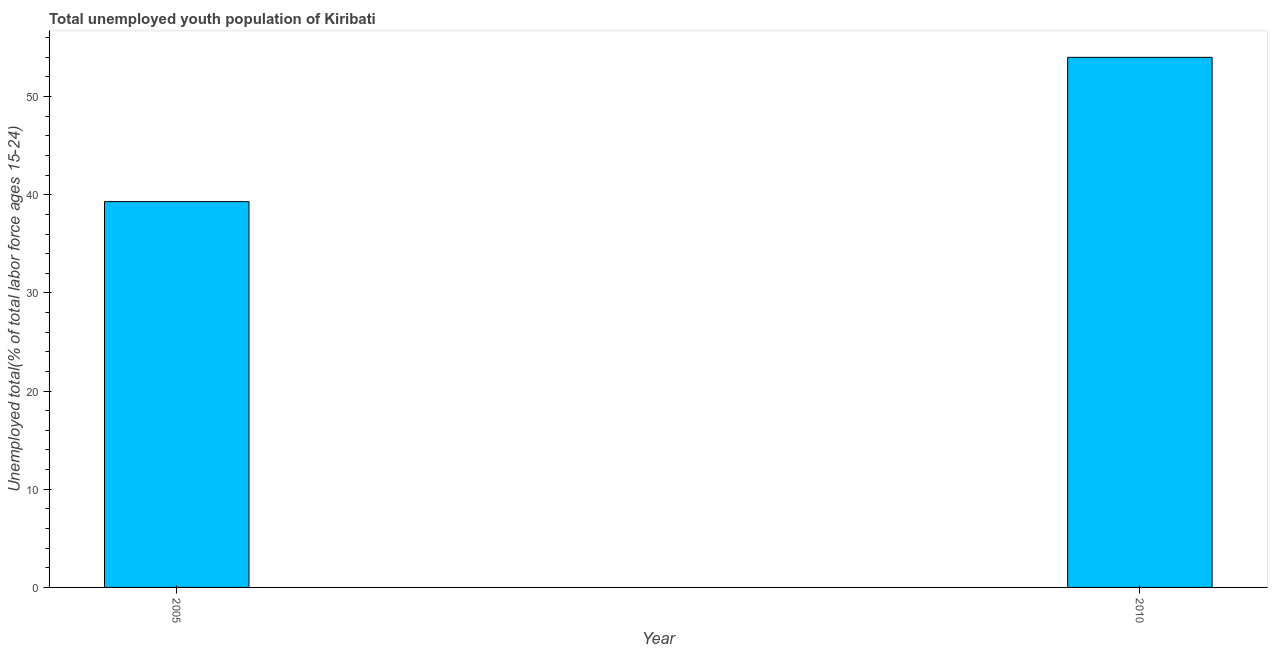Does the graph contain any zero values?
Provide a succinct answer. No. Does the graph contain grids?
Make the answer very short. No. What is the title of the graph?
Offer a very short reply. Total unemployed youth population of Kiribati. What is the label or title of the Y-axis?
Your answer should be very brief. Unemployed total(% of total labor force ages 15-24). What is the unemployed youth in 2010?
Your answer should be very brief. 54. Across all years, what is the minimum unemployed youth?
Keep it short and to the point. 39.3. What is the sum of the unemployed youth?
Your answer should be compact. 93.3. What is the difference between the unemployed youth in 2005 and 2010?
Keep it short and to the point. -14.7. What is the average unemployed youth per year?
Your answer should be very brief. 46.65. What is the median unemployed youth?
Offer a very short reply. 46.65. What is the ratio of the unemployed youth in 2005 to that in 2010?
Give a very brief answer. 0.73. Is the unemployed youth in 2005 less than that in 2010?
Your answer should be very brief. Yes. In how many years, is the unemployed youth greater than the average unemployed youth taken over all years?
Your response must be concise. 1. How many bars are there?
Give a very brief answer. 2. Are all the bars in the graph horizontal?
Your response must be concise. No. How many years are there in the graph?
Your answer should be compact. 2. What is the difference between two consecutive major ticks on the Y-axis?
Make the answer very short. 10. What is the Unemployed total(% of total labor force ages 15-24) in 2005?
Keep it short and to the point. 39.3. What is the difference between the Unemployed total(% of total labor force ages 15-24) in 2005 and 2010?
Keep it short and to the point. -14.7. What is the ratio of the Unemployed total(% of total labor force ages 15-24) in 2005 to that in 2010?
Make the answer very short. 0.73. 